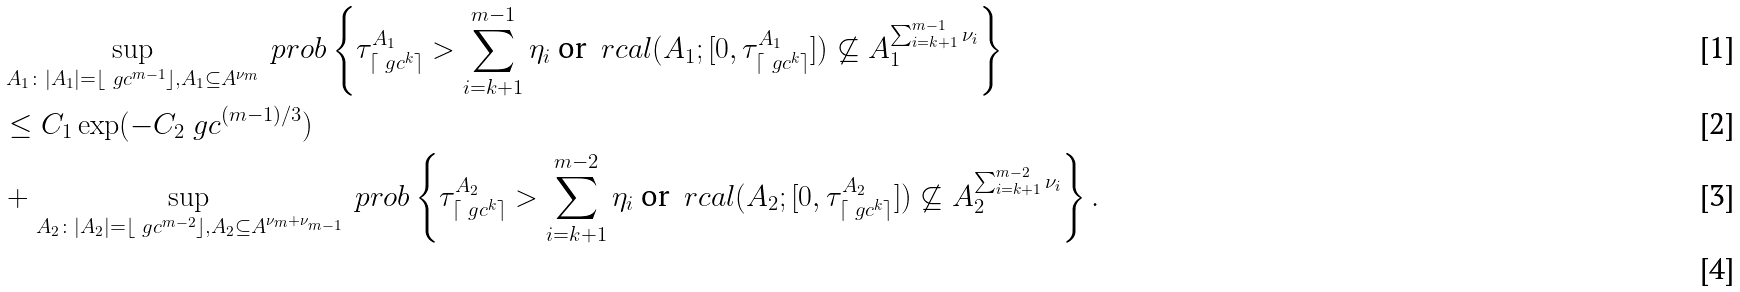<formula> <loc_0><loc_0><loc_500><loc_500>& \sup _ { A _ { 1 } \colon | A _ { 1 } | = \lfloor \ g c ^ { m - 1 } \rfloor , A _ { 1 } \subseteq A ^ { \nu _ { m } } } \ p r o b \left \{ \tau ^ { A _ { 1 } } _ { \lceil \ g c ^ { k } \rceil } > \sum _ { i = k + 1 } ^ { m - 1 } \eta _ { i } \text { or } \ r c a l ( A _ { 1 } ; [ 0 , \tau ^ { A _ { 1 } } _ { \lceil \ g c ^ { k } \rceil } ] ) \not \subseteq A _ { 1 } ^ { \sum _ { i = k + 1 } ^ { m - 1 } \nu _ { i } } \right \} \\ & \leq C _ { 1 } \exp ( - C _ { 2 } \ g c ^ { ( m - 1 ) / 3 } ) \\ & + \sup _ { A _ { 2 } \colon | A _ { 2 } | = \lfloor \ g c ^ { m - 2 } \rfloor , A _ { 2 } \subseteq A ^ { \nu _ { m } + \nu _ { m - 1 } } } \ p r o b \left \{ \tau ^ { A _ { 2 } } _ { \lceil \ g c ^ { k } \rceil } > \sum _ { i = k + 1 } ^ { m - 2 } \eta _ { i } \text { or } \ r c a l ( A _ { 2 } ; [ 0 , \tau ^ { A _ { 2 } } _ { \lceil \ g c ^ { k } \rceil } ] ) \not \subseteq A _ { 2 } ^ { \sum _ { i = k + 1 } ^ { m - 2 } \nu _ { i } } \right \} . \\</formula> 